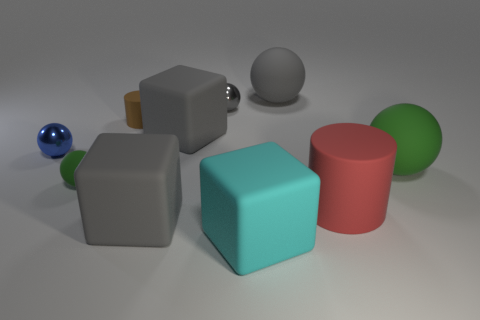Subtract all large cyan cubes. How many cubes are left? 2 Subtract all cyan blocks. How many blocks are left? 2 Subtract 2 cubes. How many cubes are left? 1 Subtract all gray cylinders. How many gray blocks are left? 2 Subtract all cylinders. How many objects are left? 8 Add 5 gray matte things. How many gray matte things are left? 8 Add 7 big blue cubes. How many big blue cubes exist? 7 Subtract 0 purple cubes. How many objects are left? 10 Subtract all gray cubes. Subtract all yellow spheres. How many cubes are left? 1 Subtract all cyan blocks. Subtract all small blue metallic spheres. How many objects are left? 8 